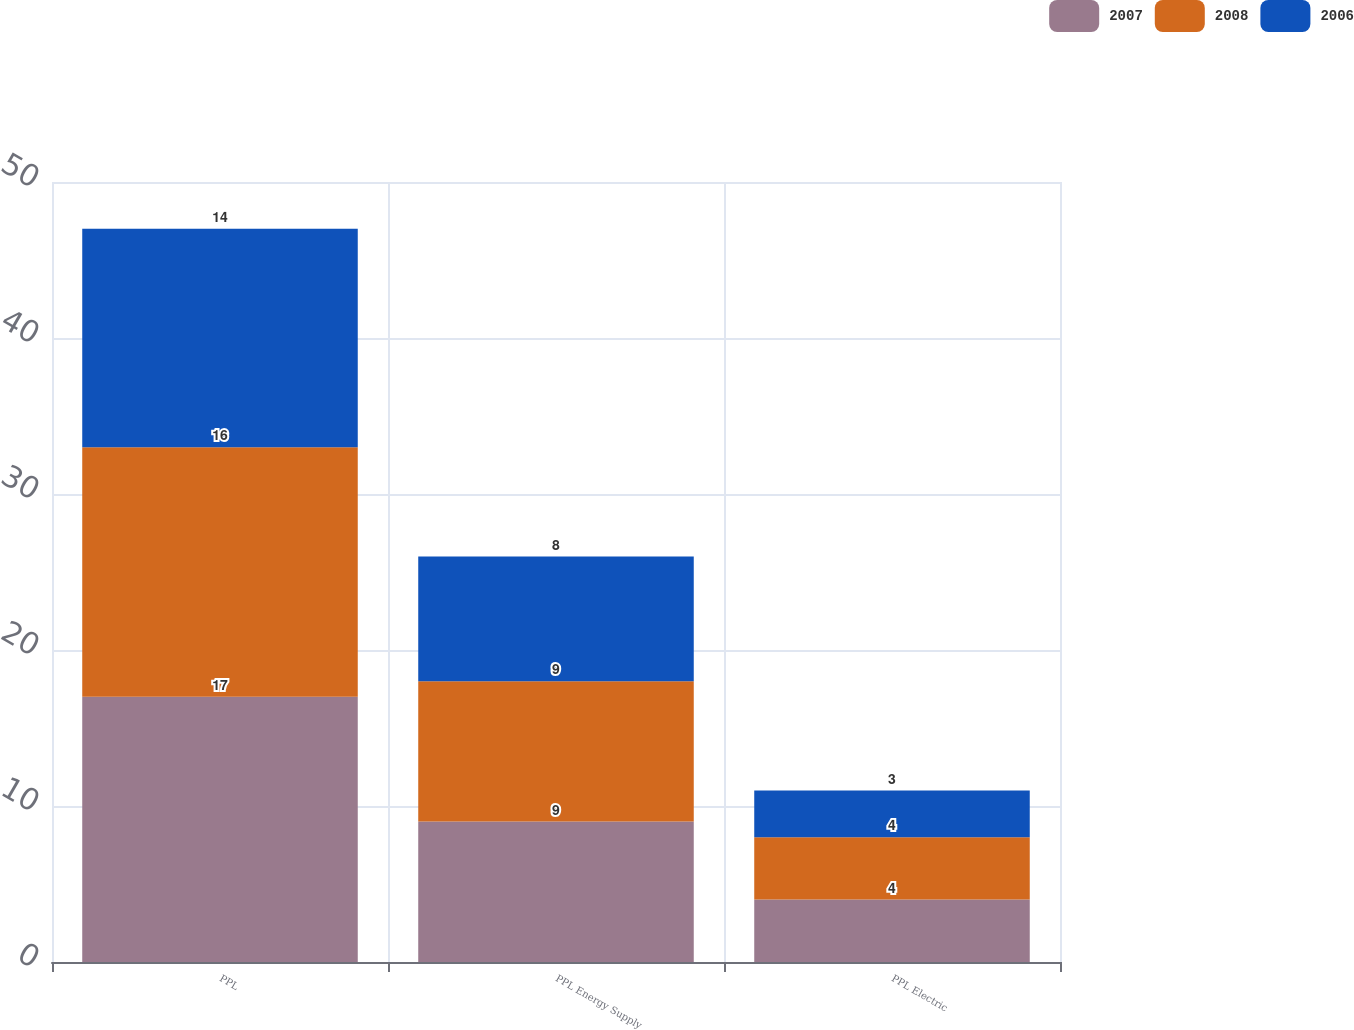Convert chart to OTSL. <chart><loc_0><loc_0><loc_500><loc_500><stacked_bar_chart><ecel><fcel>PPL<fcel>PPL Energy Supply<fcel>PPL Electric<nl><fcel>2007<fcel>17<fcel>9<fcel>4<nl><fcel>2008<fcel>16<fcel>9<fcel>4<nl><fcel>2006<fcel>14<fcel>8<fcel>3<nl></chart> 